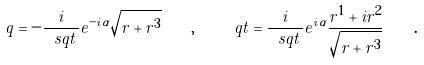Convert formula to latex. <formula><loc_0><loc_0><loc_500><loc_500>q = - \frac { i } { \ s q t \, } e ^ { - i \alpha } \sqrt { r + r ^ { 3 } } \quad , \quad \ q t = \frac { i } { \ s q t \, } e ^ { i \alpha } \frac { r ^ { 1 } + i r ^ { 2 } } { \sqrt { r + r ^ { 3 } } } \quad .</formula> 